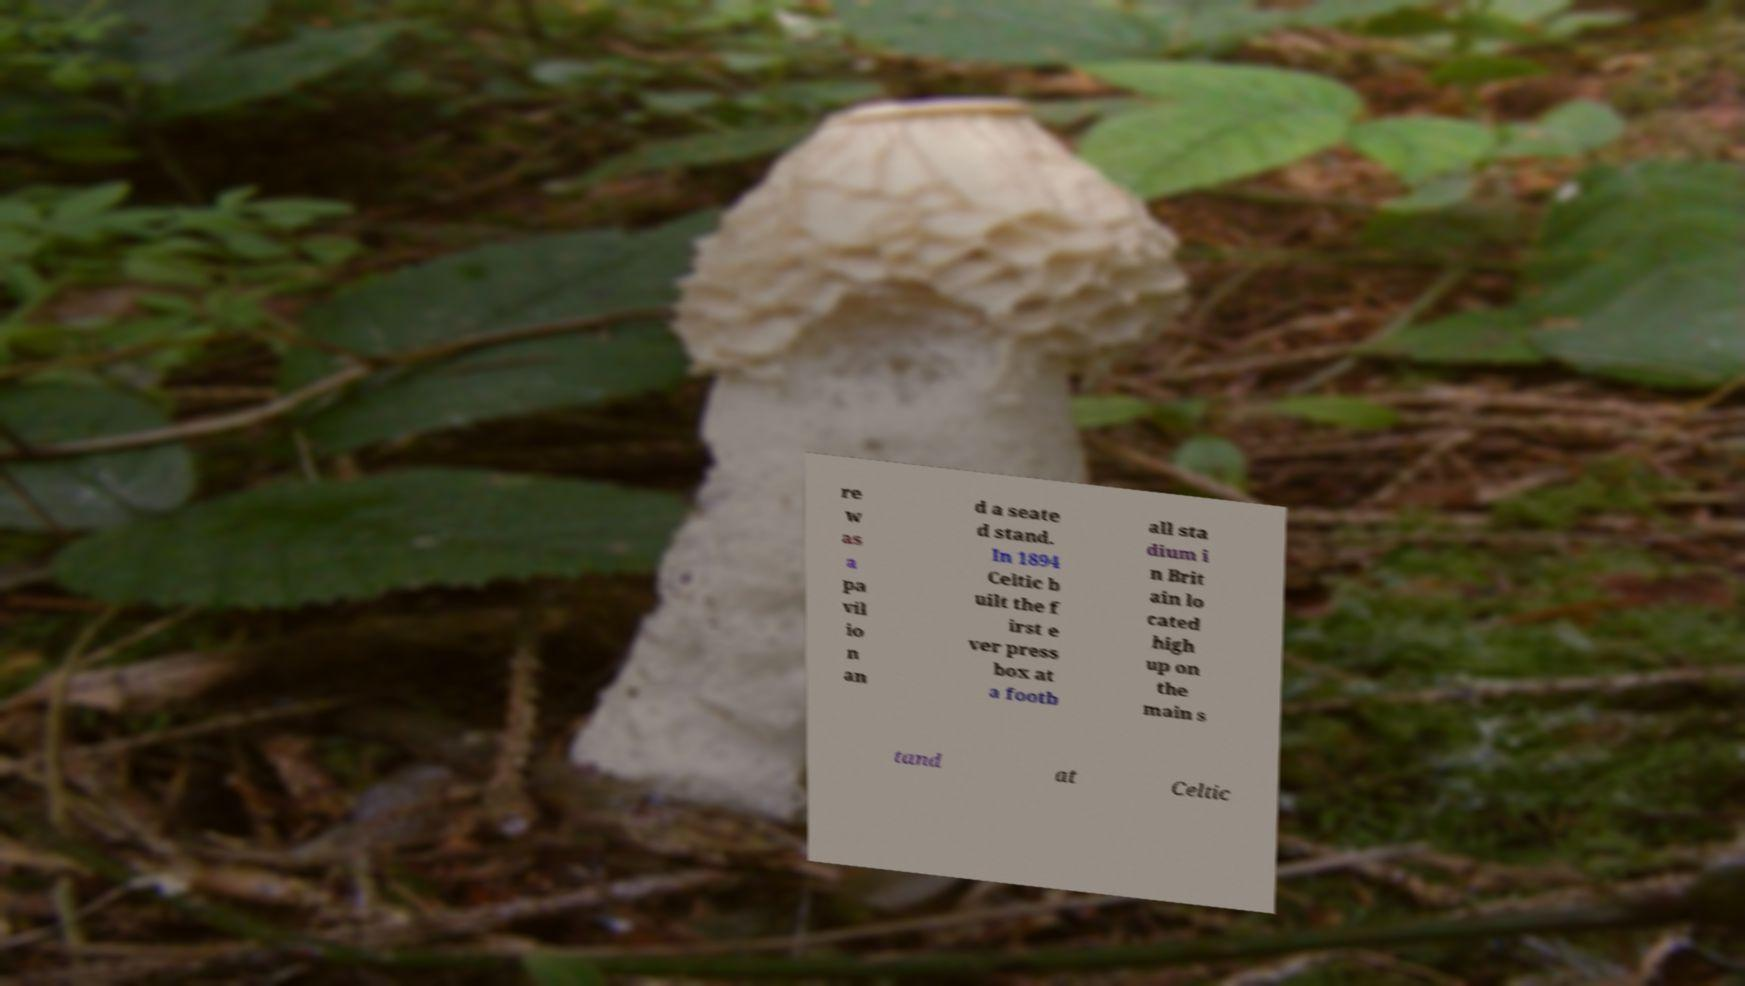Please identify and transcribe the text found in this image. re w as a pa vil io n an d a seate d stand. In 1894 Celtic b uilt the f irst e ver press box at a footb all sta dium i n Brit ain lo cated high up on the main s tand at Celtic 